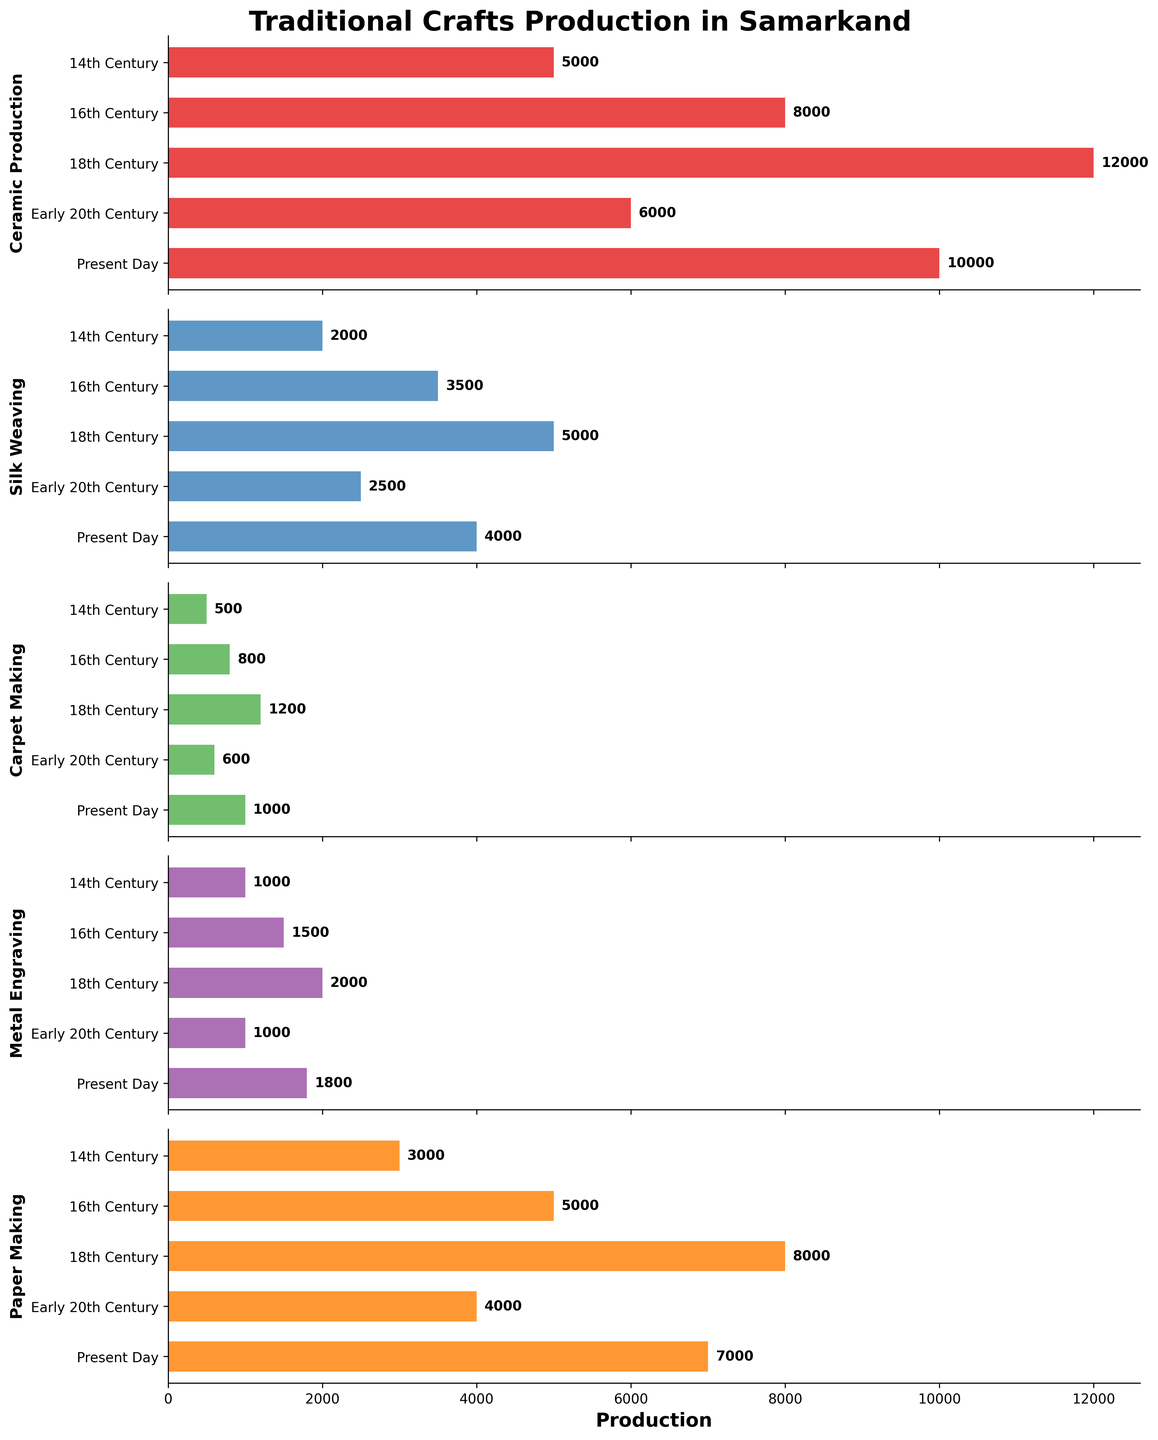What's the title of the figure? The title is displayed at the top of the figure.
Answer: Traditional Crafts Production in Samarkand Which craft had the highest production in the 18th Century? By examining the 18th Century bar in each subplot, the craft with the highest production is evident.
Answer: Ceramic Production What is the production difference in Silk Weaving between the 14th Century and the Present Day? Locate the Silk Weaving bar for the 14th Century and Present Day, and calculate the difference between these two values: 4000 - 2000 = 2000 meters.
Answer: 2000 meters Which time period saw the lowest production of Carpet Making? By comparing the heights of the Carpet Making bars in each period, the shortest bar represents the lowest production.
Answer: 14th Century How did Metal Engraving production change from the 16th Century to the 18th Century? Compare the Metal Engraving bars for the 16th and 18th Centuries: 2000 - 1500 = 500 items increase.
Answer: Increased by 500 items What's the average production of Paper Making over all time periods? Sum the production values across all periods and divide by the number of periods: (3000 + 5000 + 8000 + 4000 + 7000) / 5 = 5400 sheets.
Answer: 5400 sheets Which craft's production decreased from the 18th Century to the Early 20th Century? Identify which crafts have a lower bar in the Early 20th Century compared to the 18th Century data.
Answer: Ceramic Production Among all crafts, which had the highest recorded production across any time period? By inspecting the maximum values in each subplot, determine the highest single value recorded.
Answer: Ceramic Production in the 18th Century During which period did Carpet Making and Metal Engraving both have their highest production numbers? Find the bars with the maximum values for Carpet Making and Metal Engraving, and see if they align in any period.
Answer: 18th Century Which craft shows a consistent increase in production from the 14th Century to the Present Day? Observe the trend line for each craft's bars over time to see which one steadily increases.
Answer: Paper Making 